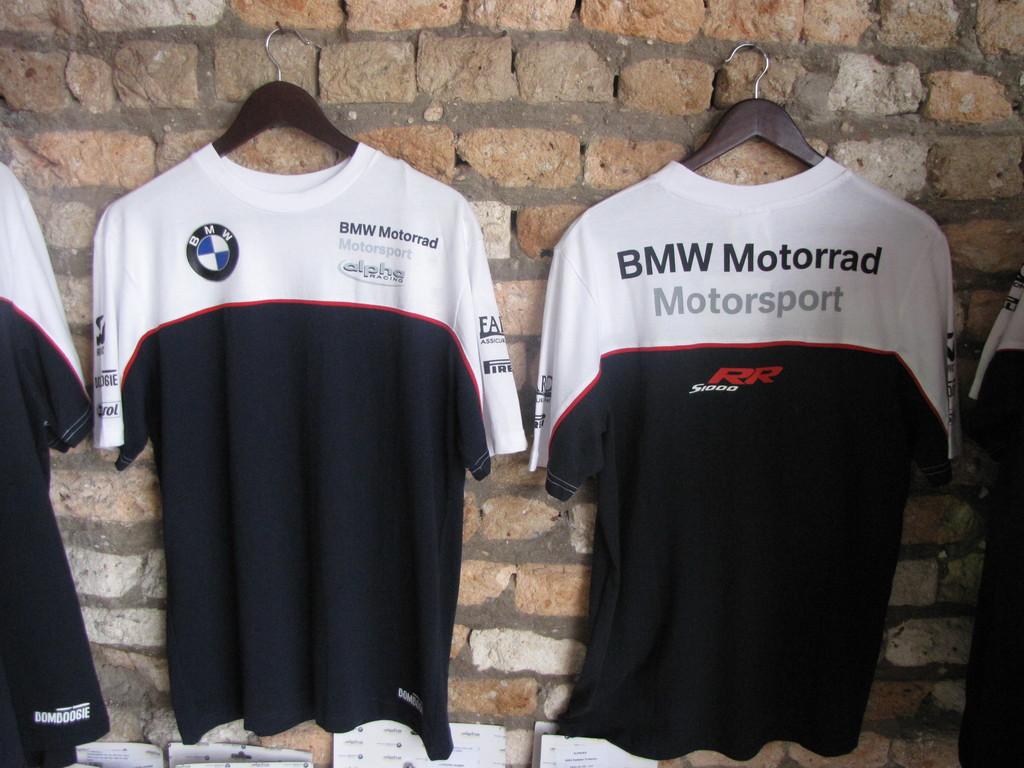What is the name on the sport shirt?
Your answer should be compact. Bmw motorrad. What auto manufacturer sponsors this company?
Your answer should be compact. Bmw. 